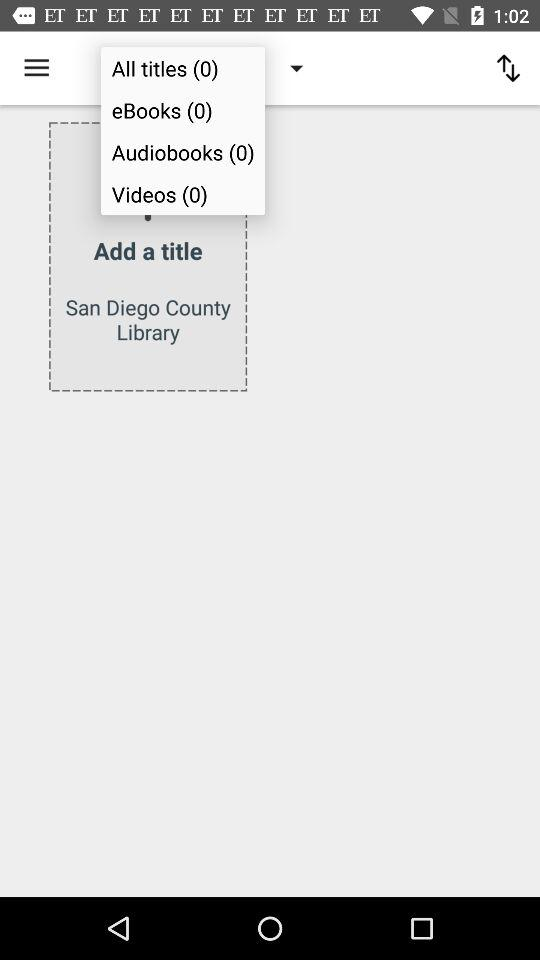How many audiobooks are there? There are zero audiobooks. 